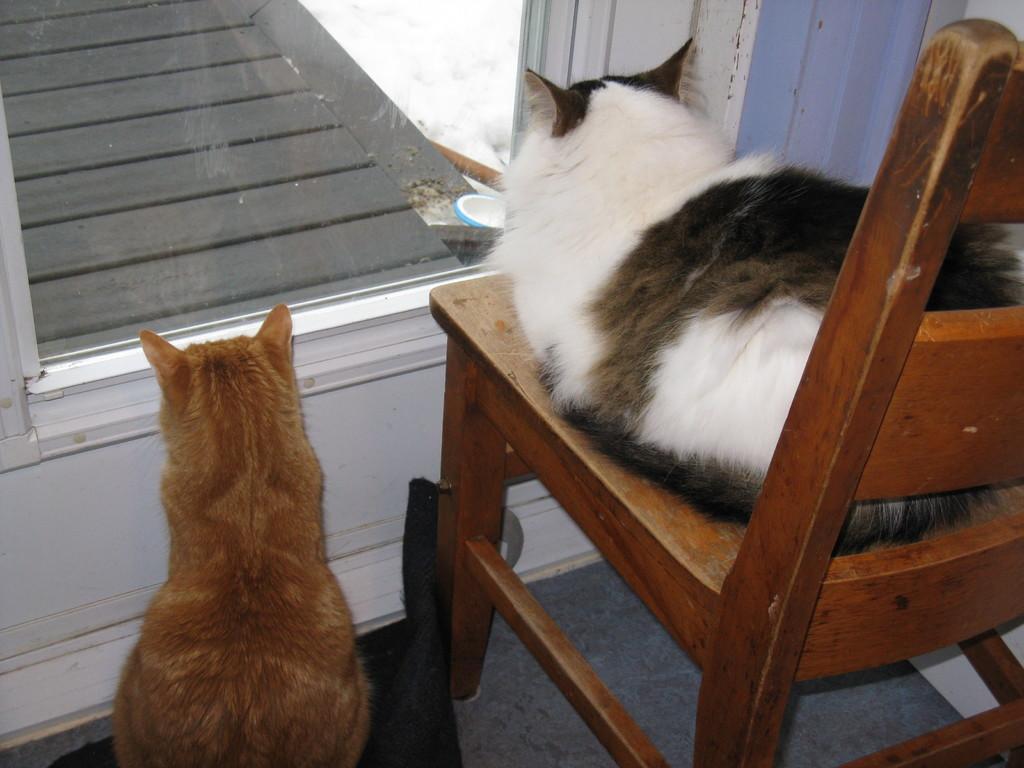Can you describe this image briefly? In the image we can see there are two cats who are sitting. 